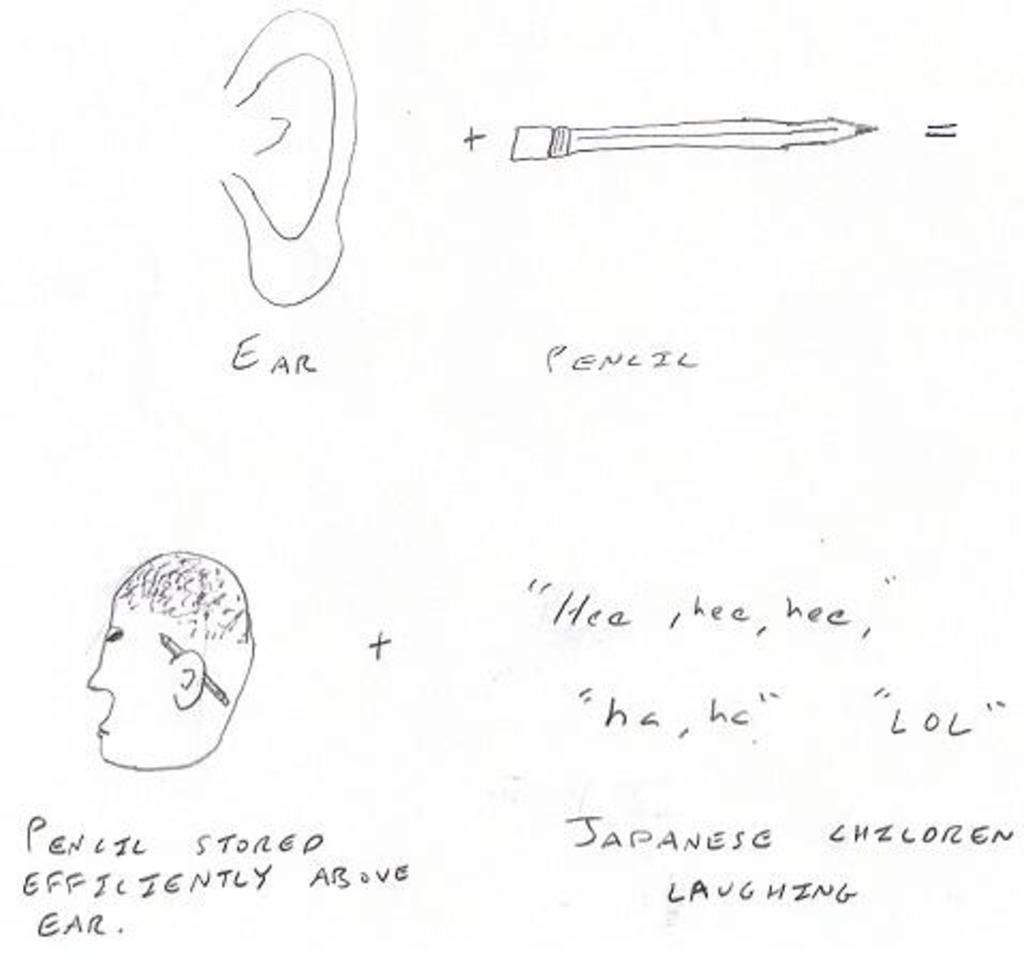Provide a one-sentence caption for the provided image. a pencil drawing of an EAR and PENCIL with the pencil put behind the ear. 